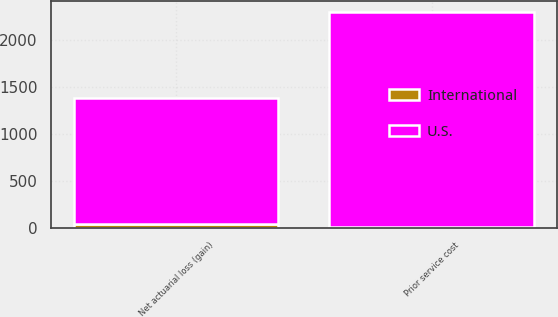Convert chart. <chart><loc_0><loc_0><loc_500><loc_500><stacked_bar_chart><ecel><fcel>Prior service cost<fcel>Net actuarial loss (gain)<nl><fcel>U.S.<fcel>2294<fcel>1355<nl><fcel>International<fcel>8<fcel>33<nl></chart> 